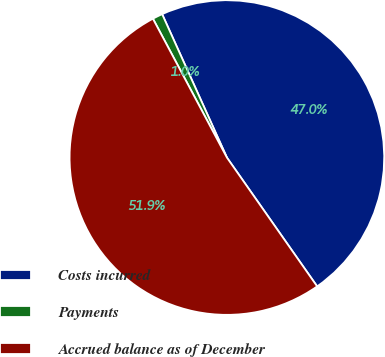Convert chart to OTSL. <chart><loc_0><loc_0><loc_500><loc_500><pie_chart><fcel>Costs incurred<fcel>Payments<fcel>Accrued balance as of December<nl><fcel>47.02%<fcel>1.04%<fcel>51.93%<nl></chart> 